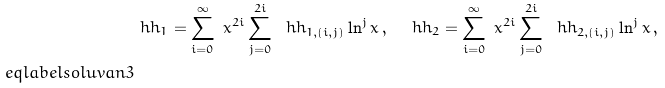<formula> <loc_0><loc_0><loc_500><loc_500>& \ h h _ { 1 } = \sum _ { i = 0 } ^ { \infty } \ x ^ { 2 i } \sum _ { j = 0 } ^ { 2 i } \ \ h h _ { 1 , ( i , j ) } \ln ^ { j } x \, , \quad \ h h _ { 2 } = \sum _ { i = 0 } ^ { \infty } \ x ^ { 2 i } \sum _ { j = 0 } ^ { 2 i } \ \ h h _ { 2 , ( i , j ) } \ln ^ { j } x \, , \\ \ e q l a b e l { s o l u v a n 3 }</formula> 